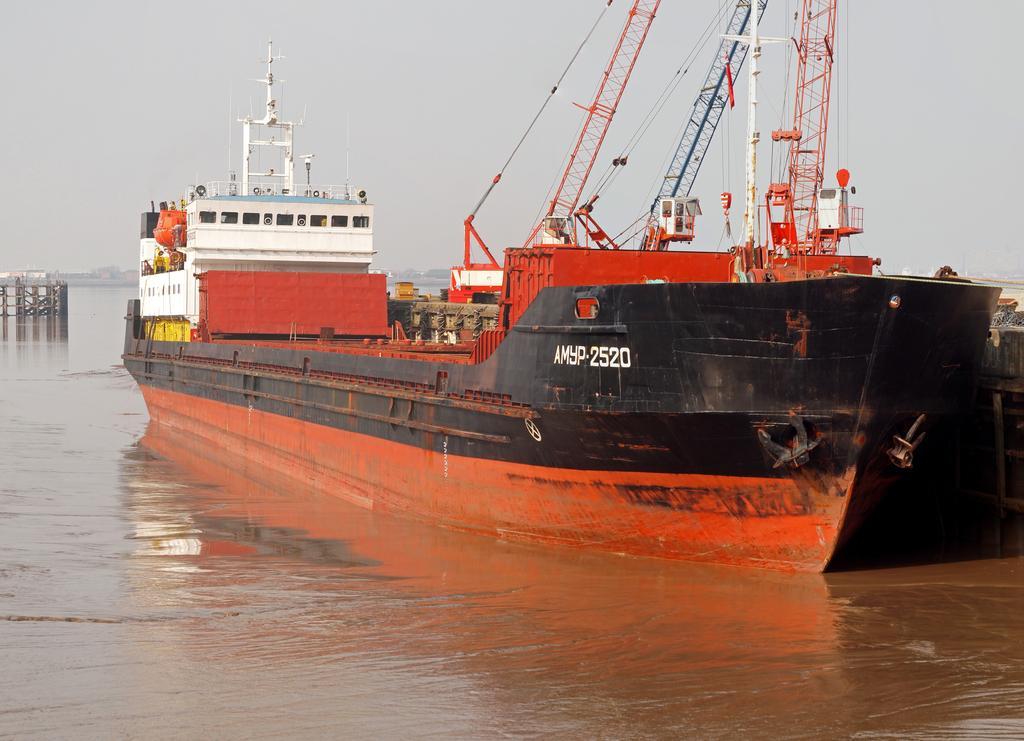How would you summarize this image in a sentence or two? In this image we can see a ship on the water. On the ship there are poles, pillars, grills, ropes and some goods. In the background we can see sky. 